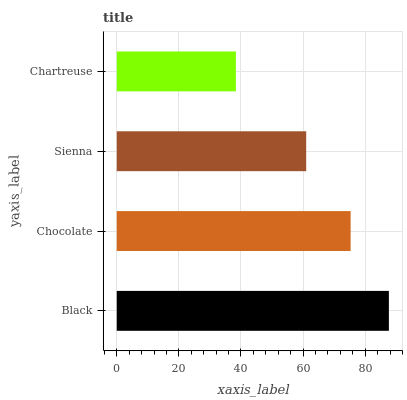Is Chartreuse the minimum?
Answer yes or no. Yes. Is Black the maximum?
Answer yes or no. Yes. Is Chocolate the minimum?
Answer yes or no. No. Is Chocolate the maximum?
Answer yes or no. No. Is Black greater than Chocolate?
Answer yes or no. Yes. Is Chocolate less than Black?
Answer yes or no. Yes. Is Chocolate greater than Black?
Answer yes or no. No. Is Black less than Chocolate?
Answer yes or no. No. Is Chocolate the high median?
Answer yes or no. Yes. Is Sienna the low median?
Answer yes or no. Yes. Is Black the high median?
Answer yes or no. No. Is Chartreuse the low median?
Answer yes or no. No. 